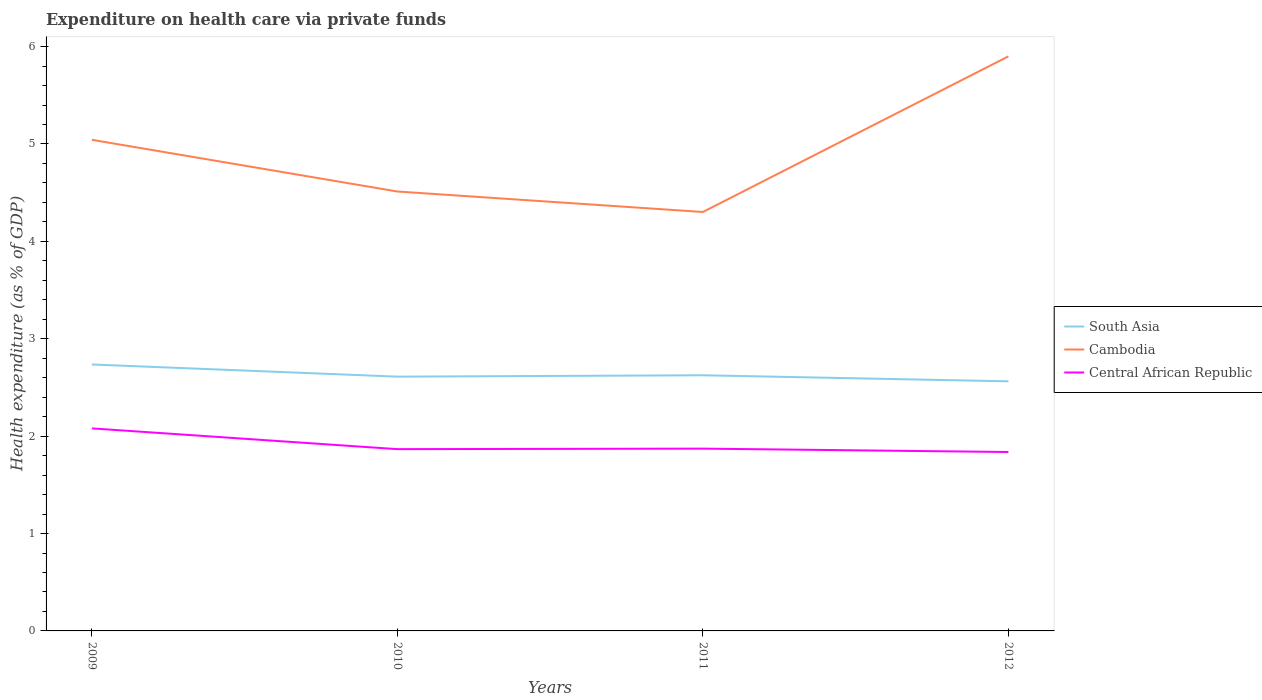Across all years, what is the maximum expenditure made on health care in Central African Republic?
Give a very brief answer. 1.84. In which year was the expenditure made on health care in Cambodia maximum?
Offer a terse response. 2011. What is the total expenditure made on health care in Central African Republic in the graph?
Offer a very short reply. -0.01. What is the difference between the highest and the second highest expenditure made on health care in Central African Republic?
Ensure brevity in your answer.  0.24. Is the expenditure made on health care in South Asia strictly greater than the expenditure made on health care in Central African Republic over the years?
Keep it short and to the point. No. How many years are there in the graph?
Provide a succinct answer. 4. What is the difference between two consecutive major ticks on the Y-axis?
Ensure brevity in your answer.  1. Where does the legend appear in the graph?
Offer a very short reply. Center right. What is the title of the graph?
Your answer should be very brief. Expenditure on health care via private funds. Does "Faeroe Islands" appear as one of the legend labels in the graph?
Give a very brief answer. No. What is the label or title of the Y-axis?
Your answer should be compact. Health expenditure (as % of GDP). What is the Health expenditure (as % of GDP) of South Asia in 2009?
Give a very brief answer. 2.74. What is the Health expenditure (as % of GDP) of Cambodia in 2009?
Provide a short and direct response. 5.04. What is the Health expenditure (as % of GDP) in Central African Republic in 2009?
Your response must be concise. 2.08. What is the Health expenditure (as % of GDP) of South Asia in 2010?
Provide a short and direct response. 2.61. What is the Health expenditure (as % of GDP) of Cambodia in 2010?
Your response must be concise. 4.51. What is the Health expenditure (as % of GDP) in Central African Republic in 2010?
Make the answer very short. 1.87. What is the Health expenditure (as % of GDP) in South Asia in 2011?
Provide a succinct answer. 2.63. What is the Health expenditure (as % of GDP) in Cambodia in 2011?
Offer a very short reply. 4.3. What is the Health expenditure (as % of GDP) of Central African Republic in 2011?
Make the answer very short. 1.87. What is the Health expenditure (as % of GDP) of South Asia in 2012?
Your response must be concise. 2.56. What is the Health expenditure (as % of GDP) of Cambodia in 2012?
Offer a terse response. 5.9. What is the Health expenditure (as % of GDP) of Central African Republic in 2012?
Your answer should be very brief. 1.84. Across all years, what is the maximum Health expenditure (as % of GDP) in South Asia?
Make the answer very short. 2.74. Across all years, what is the maximum Health expenditure (as % of GDP) of Cambodia?
Your answer should be very brief. 5.9. Across all years, what is the maximum Health expenditure (as % of GDP) of Central African Republic?
Offer a very short reply. 2.08. Across all years, what is the minimum Health expenditure (as % of GDP) of South Asia?
Your answer should be compact. 2.56. Across all years, what is the minimum Health expenditure (as % of GDP) in Cambodia?
Your answer should be compact. 4.3. Across all years, what is the minimum Health expenditure (as % of GDP) of Central African Republic?
Offer a terse response. 1.84. What is the total Health expenditure (as % of GDP) in South Asia in the graph?
Offer a terse response. 10.53. What is the total Health expenditure (as % of GDP) of Cambodia in the graph?
Your response must be concise. 19.76. What is the total Health expenditure (as % of GDP) in Central African Republic in the graph?
Provide a short and direct response. 7.66. What is the difference between the Health expenditure (as % of GDP) in South Asia in 2009 and that in 2010?
Keep it short and to the point. 0.12. What is the difference between the Health expenditure (as % of GDP) in Cambodia in 2009 and that in 2010?
Make the answer very short. 0.53. What is the difference between the Health expenditure (as % of GDP) of Central African Republic in 2009 and that in 2010?
Your response must be concise. 0.21. What is the difference between the Health expenditure (as % of GDP) in South Asia in 2009 and that in 2011?
Keep it short and to the point. 0.11. What is the difference between the Health expenditure (as % of GDP) of Cambodia in 2009 and that in 2011?
Offer a terse response. 0.74. What is the difference between the Health expenditure (as % of GDP) of Central African Republic in 2009 and that in 2011?
Make the answer very short. 0.21. What is the difference between the Health expenditure (as % of GDP) of South Asia in 2009 and that in 2012?
Your answer should be very brief. 0.17. What is the difference between the Health expenditure (as % of GDP) of Cambodia in 2009 and that in 2012?
Make the answer very short. -0.86. What is the difference between the Health expenditure (as % of GDP) of Central African Republic in 2009 and that in 2012?
Keep it short and to the point. 0.24. What is the difference between the Health expenditure (as % of GDP) in South Asia in 2010 and that in 2011?
Make the answer very short. -0.01. What is the difference between the Health expenditure (as % of GDP) in Cambodia in 2010 and that in 2011?
Your answer should be compact. 0.21. What is the difference between the Health expenditure (as % of GDP) of Central African Republic in 2010 and that in 2011?
Your answer should be very brief. -0.01. What is the difference between the Health expenditure (as % of GDP) in South Asia in 2010 and that in 2012?
Keep it short and to the point. 0.05. What is the difference between the Health expenditure (as % of GDP) of Cambodia in 2010 and that in 2012?
Keep it short and to the point. -1.39. What is the difference between the Health expenditure (as % of GDP) of Central African Republic in 2010 and that in 2012?
Keep it short and to the point. 0.03. What is the difference between the Health expenditure (as % of GDP) of South Asia in 2011 and that in 2012?
Make the answer very short. 0.06. What is the difference between the Health expenditure (as % of GDP) in Cambodia in 2011 and that in 2012?
Provide a succinct answer. -1.6. What is the difference between the Health expenditure (as % of GDP) of Central African Republic in 2011 and that in 2012?
Provide a succinct answer. 0.03. What is the difference between the Health expenditure (as % of GDP) of South Asia in 2009 and the Health expenditure (as % of GDP) of Cambodia in 2010?
Your answer should be compact. -1.78. What is the difference between the Health expenditure (as % of GDP) of South Asia in 2009 and the Health expenditure (as % of GDP) of Central African Republic in 2010?
Provide a short and direct response. 0.87. What is the difference between the Health expenditure (as % of GDP) of Cambodia in 2009 and the Health expenditure (as % of GDP) of Central African Republic in 2010?
Offer a terse response. 3.18. What is the difference between the Health expenditure (as % of GDP) of South Asia in 2009 and the Health expenditure (as % of GDP) of Cambodia in 2011?
Make the answer very short. -1.57. What is the difference between the Health expenditure (as % of GDP) in South Asia in 2009 and the Health expenditure (as % of GDP) in Central African Republic in 2011?
Your answer should be very brief. 0.86. What is the difference between the Health expenditure (as % of GDP) in Cambodia in 2009 and the Health expenditure (as % of GDP) in Central African Republic in 2011?
Provide a succinct answer. 3.17. What is the difference between the Health expenditure (as % of GDP) in South Asia in 2009 and the Health expenditure (as % of GDP) in Cambodia in 2012?
Your answer should be compact. -3.16. What is the difference between the Health expenditure (as % of GDP) of South Asia in 2009 and the Health expenditure (as % of GDP) of Central African Republic in 2012?
Make the answer very short. 0.9. What is the difference between the Health expenditure (as % of GDP) in Cambodia in 2009 and the Health expenditure (as % of GDP) in Central African Republic in 2012?
Provide a succinct answer. 3.21. What is the difference between the Health expenditure (as % of GDP) of South Asia in 2010 and the Health expenditure (as % of GDP) of Cambodia in 2011?
Your response must be concise. -1.69. What is the difference between the Health expenditure (as % of GDP) in South Asia in 2010 and the Health expenditure (as % of GDP) in Central African Republic in 2011?
Keep it short and to the point. 0.74. What is the difference between the Health expenditure (as % of GDP) of Cambodia in 2010 and the Health expenditure (as % of GDP) of Central African Republic in 2011?
Make the answer very short. 2.64. What is the difference between the Health expenditure (as % of GDP) in South Asia in 2010 and the Health expenditure (as % of GDP) in Cambodia in 2012?
Your response must be concise. -3.29. What is the difference between the Health expenditure (as % of GDP) of South Asia in 2010 and the Health expenditure (as % of GDP) of Central African Republic in 2012?
Give a very brief answer. 0.77. What is the difference between the Health expenditure (as % of GDP) of Cambodia in 2010 and the Health expenditure (as % of GDP) of Central African Republic in 2012?
Your answer should be compact. 2.68. What is the difference between the Health expenditure (as % of GDP) in South Asia in 2011 and the Health expenditure (as % of GDP) in Cambodia in 2012?
Ensure brevity in your answer.  -3.27. What is the difference between the Health expenditure (as % of GDP) of South Asia in 2011 and the Health expenditure (as % of GDP) of Central African Republic in 2012?
Ensure brevity in your answer.  0.79. What is the difference between the Health expenditure (as % of GDP) of Cambodia in 2011 and the Health expenditure (as % of GDP) of Central African Republic in 2012?
Ensure brevity in your answer.  2.46. What is the average Health expenditure (as % of GDP) in South Asia per year?
Provide a short and direct response. 2.63. What is the average Health expenditure (as % of GDP) in Cambodia per year?
Your answer should be compact. 4.94. What is the average Health expenditure (as % of GDP) in Central African Republic per year?
Make the answer very short. 1.91. In the year 2009, what is the difference between the Health expenditure (as % of GDP) in South Asia and Health expenditure (as % of GDP) in Cambodia?
Your answer should be very brief. -2.31. In the year 2009, what is the difference between the Health expenditure (as % of GDP) in South Asia and Health expenditure (as % of GDP) in Central African Republic?
Give a very brief answer. 0.66. In the year 2009, what is the difference between the Health expenditure (as % of GDP) in Cambodia and Health expenditure (as % of GDP) in Central African Republic?
Your answer should be compact. 2.96. In the year 2010, what is the difference between the Health expenditure (as % of GDP) in South Asia and Health expenditure (as % of GDP) in Cambodia?
Make the answer very short. -1.9. In the year 2010, what is the difference between the Health expenditure (as % of GDP) in South Asia and Health expenditure (as % of GDP) in Central African Republic?
Ensure brevity in your answer.  0.74. In the year 2010, what is the difference between the Health expenditure (as % of GDP) of Cambodia and Health expenditure (as % of GDP) of Central African Republic?
Make the answer very short. 2.65. In the year 2011, what is the difference between the Health expenditure (as % of GDP) of South Asia and Health expenditure (as % of GDP) of Cambodia?
Your response must be concise. -1.68. In the year 2011, what is the difference between the Health expenditure (as % of GDP) in South Asia and Health expenditure (as % of GDP) in Central African Republic?
Give a very brief answer. 0.75. In the year 2011, what is the difference between the Health expenditure (as % of GDP) in Cambodia and Health expenditure (as % of GDP) in Central African Republic?
Keep it short and to the point. 2.43. In the year 2012, what is the difference between the Health expenditure (as % of GDP) of South Asia and Health expenditure (as % of GDP) of Cambodia?
Make the answer very short. -3.34. In the year 2012, what is the difference between the Health expenditure (as % of GDP) in South Asia and Health expenditure (as % of GDP) in Central African Republic?
Your answer should be very brief. 0.73. In the year 2012, what is the difference between the Health expenditure (as % of GDP) of Cambodia and Health expenditure (as % of GDP) of Central African Republic?
Your response must be concise. 4.06. What is the ratio of the Health expenditure (as % of GDP) in South Asia in 2009 to that in 2010?
Make the answer very short. 1.05. What is the ratio of the Health expenditure (as % of GDP) of Cambodia in 2009 to that in 2010?
Ensure brevity in your answer.  1.12. What is the ratio of the Health expenditure (as % of GDP) of Central African Republic in 2009 to that in 2010?
Give a very brief answer. 1.11. What is the ratio of the Health expenditure (as % of GDP) in South Asia in 2009 to that in 2011?
Make the answer very short. 1.04. What is the ratio of the Health expenditure (as % of GDP) in Cambodia in 2009 to that in 2011?
Provide a succinct answer. 1.17. What is the ratio of the Health expenditure (as % of GDP) of Central African Republic in 2009 to that in 2011?
Offer a very short reply. 1.11. What is the ratio of the Health expenditure (as % of GDP) in South Asia in 2009 to that in 2012?
Your answer should be very brief. 1.07. What is the ratio of the Health expenditure (as % of GDP) in Cambodia in 2009 to that in 2012?
Ensure brevity in your answer.  0.85. What is the ratio of the Health expenditure (as % of GDP) in Central African Republic in 2009 to that in 2012?
Offer a very short reply. 1.13. What is the ratio of the Health expenditure (as % of GDP) in South Asia in 2010 to that in 2011?
Your response must be concise. 0.99. What is the ratio of the Health expenditure (as % of GDP) in Cambodia in 2010 to that in 2011?
Keep it short and to the point. 1.05. What is the ratio of the Health expenditure (as % of GDP) of Central African Republic in 2010 to that in 2011?
Offer a terse response. 1. What is the ratio of the Health expenditure (as % of GDP) of South Asia in 2010 to that in 2012?
Offer a very short reply. 1.02. What is the ratio of the Health expenditure (as % of GDP) in Cambodia in 2010 to that in 2012?
Provide a short and direct response. 0.76. What is the ratio of the Health expenditure (as % of GDP) of Central African Republic in 2010 to that in 2012?
Provide a succinct answer. 1.02. What is the ratio of the Health expenditure (as % of GDP) of South Asia in 2011 to that in 2012?
Your answer should be very brief. 1.02. What is the ratio of the Health expenditure (as % of GDP) of Cambodia in 2011 to that in 2012?
Make the answer very short. 0.73. What is the difference between the highest and the second highest Health expenditure (as % of GDP) of South Asia?
Offer a terse response. 0.11. What is the difference between the highest and the second highest Health expenditure (as % of GDP) in Cambodia?
Make the answer very short. 0.86. What is the difference between the highest and the second highest Health expenditure (as % of GDP) of Central African Republic?
Give a very brief answer. 0.21. What is the difference between the highest and the lowest Health expenditure (as % of GDP) of South Asia?
Ensure brevity in your answer.  0.17. What is the difference between the highest and the lowest Health expenditure (as % of GDP) in Cambodia?
Make the answer very short. 1.6. What is the difference between the highest and the lowest Health expenditure (as % of GDP) of Central African Republic?
Your answer should be very brief. 0.24. 